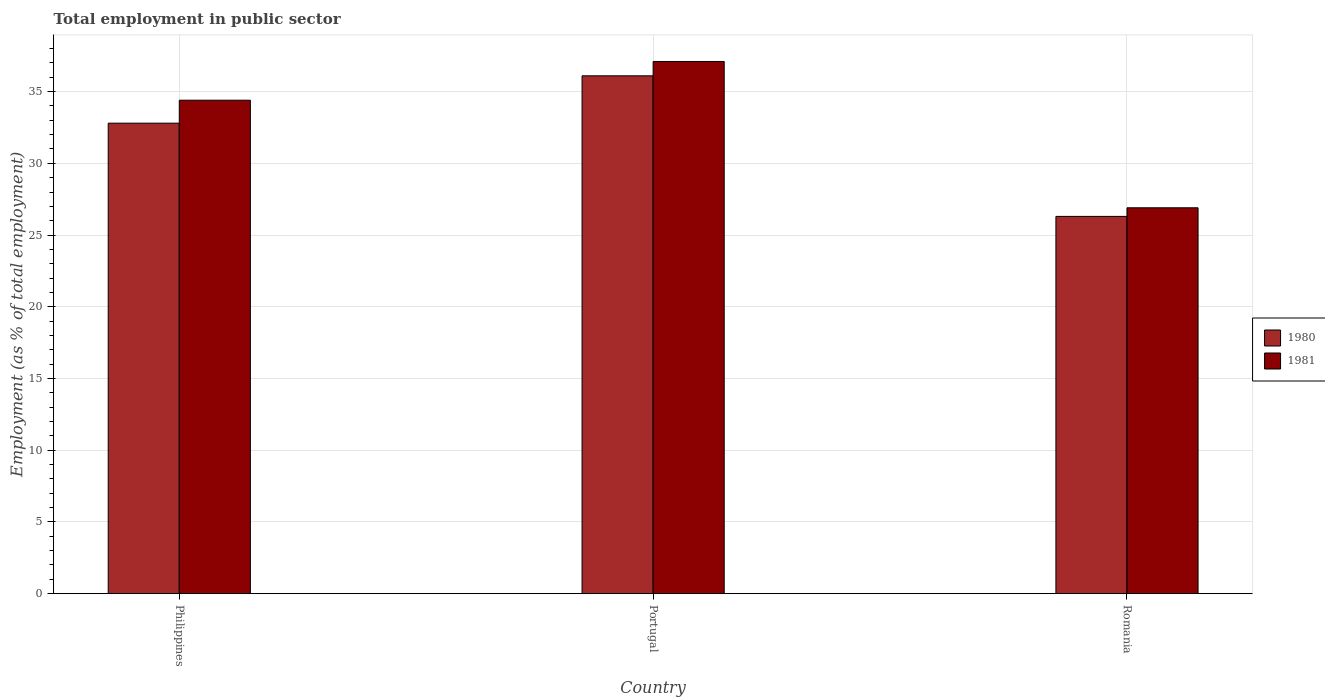How many groups of bars are there?
Keep it short and to the point. 3. How many bars are there on the 3rd tick from the right?
Your response must be concise. 2. In how many cases, is the number of bars for a given country not equal to the number of legend labels?
Provide a short and direct response. 0. What is the employment in public sector in 1980 in Philippines?
Offer a very short reply. 32.8. Across all countries, what is the maximum employment in public sector in 1981?
Provide a succinct answer. 37.1. Across all countries, what is the minimum employment in public sector in 1981?
Offer a terse response. 26.9. In which country was the employment in public sector in 1981 maximum?
Your response must be concise. Portugal. In which country was the employment in public sector in 1980 minimum?
Provide a succinct answer. Romania. What is the total employment in public sector in 1980 in the graph?
Give a very brief answer. 95.2. What is the difference between the employment in public sector in 1980 in Philippines and that in Portugal?
Your answer should be very brief. -3.3. What is the difference between the employment in public sector in 1981 in Romania and the employment in public sector in 1980 in Philippines?
Ensure brevity in your answer.  -5.9. What is the average employment in public sector in 1981 per country?
Ensure brevity in your answer.  32.8. What is the difference between the employment in public sector of/in 1981 and employment in public sector of/in 1980 in Portugal?
Provide a short and direct response. 1. In how many countries, is the employment in public sector in 1980 greater than 14 %?
Ensure brevity in your answer.  3. What is the ratio of the employment in public sector in 1981 in Philippines to that in Romania?
Provide a succinct answer. 1.28. Is the employment in public sector in 1980 in Portugal less than that in Romania?
Keep it short and to the point. No. Is the difference between the employment in public sector in 1981 in Philippines and Romania greater than the difference between the employment in public sector in 1980 in Philippines and Romania?
Your answer should be compact. Yes. What is the difference between the highest and the second highest employment in public sector in 1981?
Keep it short and to the point. 7.5. What is the difference between the highest and the lowest employment in public sector in 1981?
Provide a short and direct response. 10.2. In how many countries, is the employment in public sector in 1981 greater than the average employment in public sector in 1981 taken over all countries?
Make the answer very short. 2. Is the sum of the employment in public sector in 1981 in Philippines and Romania greater than the maximum employment in public sector in 1980 across all countries?
Offer a very short reply. Yes. What does the 1st bar from the right in Philippines represents?
Offer a very short reply. 1981. How many countries are there in the graph?
Provide a short and direct response. 3. Are the values on the major ticks of Y-axis written in scientific E-notation?
Keep it short and to the point. No. Does the graph contain any zero values?
Make the answer very short. No. Where does the legend appear in the graph?
Offer a terse response. Center right. What is the title of the graph?
Your answer should be very brief. Total employment in public sector. Does "2010" appear as one of the legend labels in the graph?
Give a very brief answer. No. What is the label or title of the X-axis?
Provide a succinct answer. Country. What is the label or title of the Y-axis?
Provide a succinct answer. Employment (as % of total employment). What is the Employment (as % of total employment) in 1980 in Philippines?
Make the answer very short. 32.8. What is the Employment (as % of total employment) in 1981 in Philippines?
Keep it short and to the point. 34.4. What is the Employment (as % of total employment) in 1980 in Portugal?
Make the answer very short. 36.1. What is the Employment (as % of total employment) in 1981 in Portugal?
Your answer should be compact. 37.1. What is the Employment (as % of total employment) of 1980 in Romania?
Provide a succinct answer. 26.3. What is the Employment (as % of total employment) in 1981 in Romania?
Provide a succinct answer. 26.9. Across all countries, what is the maximum Employment (as % of total employment) in 1980?
Offer a terse response. 36.1. Across all countries, what is the maximum Employment (as % of total employment) of 1981?
Offer a very short reply. 37.1. Across all countries, what is the minimum Employment (as % of total employment) of 1980?
Give a very brief answer. 26.3. Across all countries, what is the minimum Employment (as % of total employment) in 1981?
Provide a succinct answer. 26.9. What is the total Employment (as % of total employment) in 1980 in the graph?
Offer a terse response. 95.2. What is the total Employment (as % of total employment) of 1981 in the graph?
Offer a terse response. 98.4. What is the difference between the Employment (as % of total employment) in 1980 in Philippines and that in Portugal?
Provide a short and direct response. -3.3. What is the difference between the Employment (as % of total employment) in 1981 in Philippines and that in Portugal?
Your response must be concise. -2.7. What is the difference between the Employment (as % of total employment) in 1981 in Philippines and that in Romania?
Provide a short and direct response. 7.5. What is the difference between the Employment (as % of total employment) in 1981 in Portugal and that in Romania?
Provide a short and direct response. 10.2. What is the difference between the Employment (as % of total employment) of 1980 in Philippines and the Employment (as % of total employment) of 1981 in Romania?
Ensure brevity in your answer.  5.9. What is the difference between the Employment (as % of total employment) of 1980 in Portugal and the Employment (as % of total employment) of 1981 in Romania?
Your answer should be very brief. 9.2. What is the average Employment (as % of total employment) of 1980 per country?
Offer a very short reply. 31.73. What is the average Employment (as % of total employment) of 1981 per country?
Give a very brief answer. 32.8. What is the difference between the Employment (as % of total employment) in 1980 and Employment (as % of total employment) in 1981 in Philippines?
Give a very brief answer. -1.6. What is the difference between the Employment (as % of total employment) in 1980 and Employment (as % of total employment) in 1981 in Romania?
Provide a succinct answer. -0.6. What is the ratio of the Employment (as % of total employment) of 1980 in Philippines to that in Portugal?
Offer a very short reply. 0.91. What is the ratio of the Employment (as % of total employment) of 1981 in Philippines to that in Portugal?
Keep it short and to the point. 0.93. What is the ratio of the Employment (as % of total employment) of 1980 in Philippines to that in Romania?
Offer a very short reply. 1.25. What is the ratio of the Employment (as % of total employment) in 1981 in Philippines to that in Romania?
Make the answer very short. 1.28. What is the ratio of the Employment (as % of total employment) in 1980 in Portugal to that in Romania?
Offer a terse response. 1.37. What is the ratio of the Employment (as % of total employment) in 1981 in Portugal to that in Romania?
Your answer should be very brief. 1.38. What is the difference between the highest and the second highest Employment (as % of total employment) of 1980?
Your answer should be very brief. 3.3. What is the difference between the highest and the second highest Employment (as % of total employment) in 1981?
Provide a short and direct response. 2.7. 